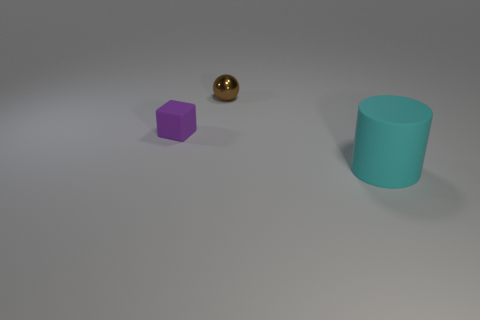Are there any other things that have the same size as the cylinder?
Give a very brief answer. No. Is there any other thing that is the same shape as the cyan matte object?
Ensure brevity in your answer.  No. What number of small metallic things are on the left side of the rubber thing behind the matte object that is on the right side of the small purple matte block?
Your answer should be very brief. 0. There is a tiny purple object; how many objects are behind it?
Your response must be concise. 1. How many tiny purple objects have the same material as the tiny purple block?
Your answer should be very brief. 0. There is a cube that is made of the same material as the big cylinder; what color is it?
Ensure brevity in your answer.  Purple. There is a object that is left of the small object that is behind the matte object behind the big cyan rubber thing; what is its material?
Ensure brevity in your answer.  Rubber. Does the rubber object that is on the left side of the cyan thing have the same size as the tiny brown metal object?
Offer a very short reply. Yes. What number of tiny things are red spheres or balls?
Provide a succinct answer. 1. There is a thing that is the same size as the brown ball; what is its shape?
Your response must be concise. Cube. 